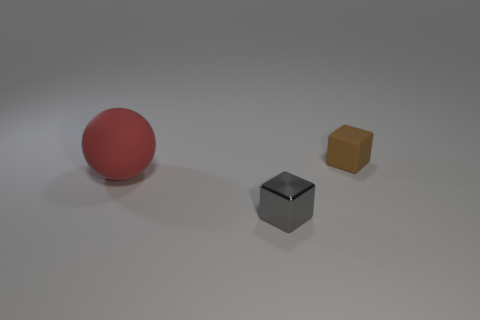Add 1 rubber objects. How many objects exist? 4 Subtract all balls. How many objects are left? 2 Add 2 brown rubber objects. How many brown rubber objects are left? 3 Add 3 big matte balls. How many big matte balls exist? 4 Subtract 0 purple cylinders. How many objects are left? 3 Subtract all tiny metallic things. Subtract all large cyan metal blocks. How many objects are left? 2 